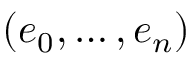Convert formula to latex. <formula><loc_0><loc_0><loc_500><loc_500>( e _ { 0 } , \dots , e _ { n } )</formula> 